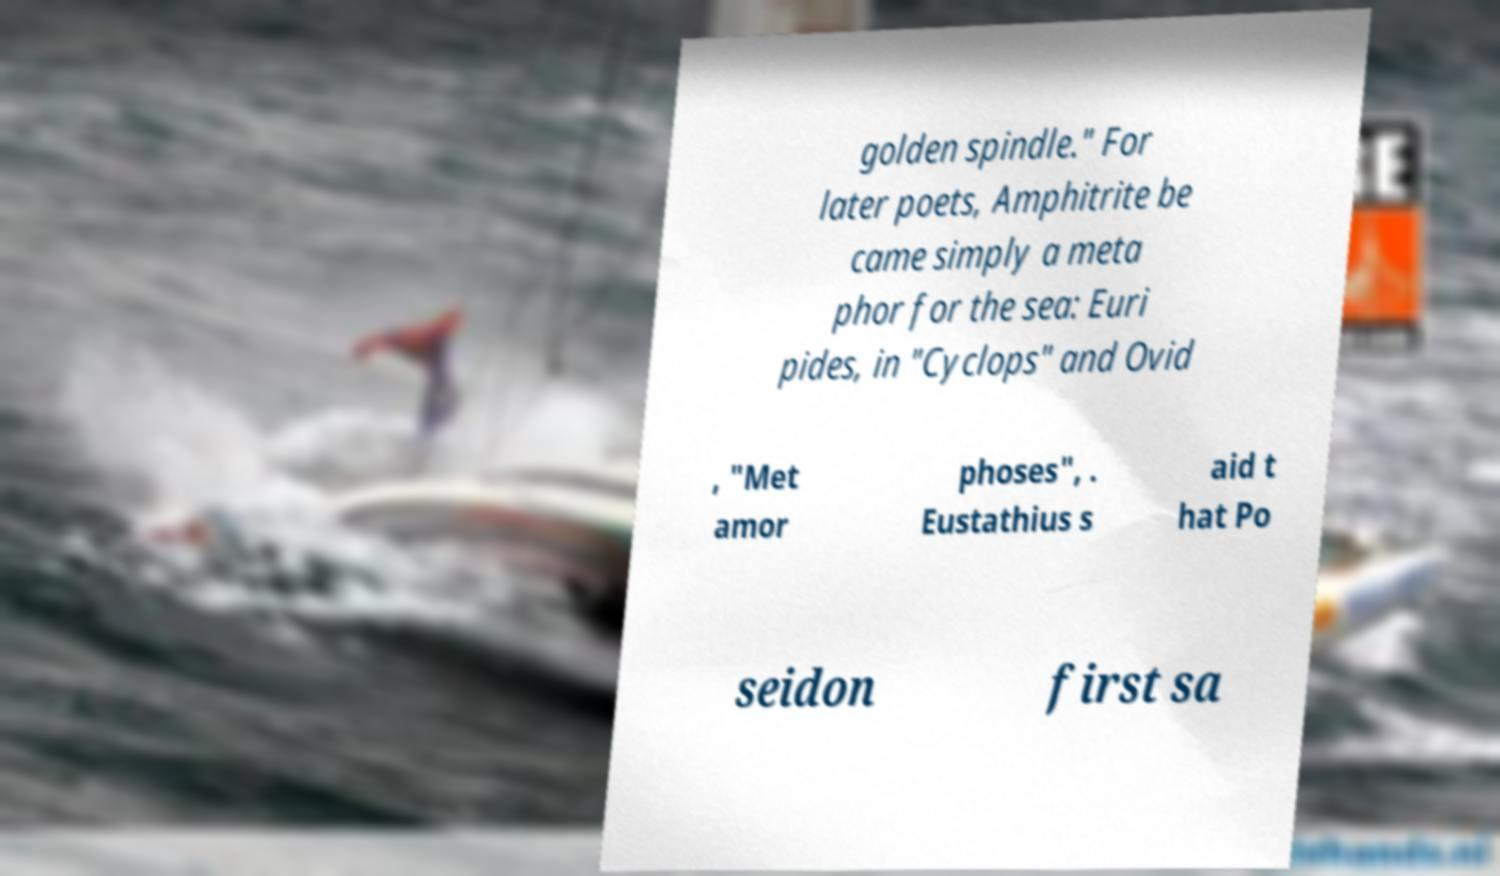Please identify and transcribe the text found in this image. golden spindle." For later poets, Amphitrite be came simply a meta phor for the sea: Euri pides, in "Cyclops" and Ovid , "Met amor phoses", . Eustathius s aid t hat Po seidon first sa 